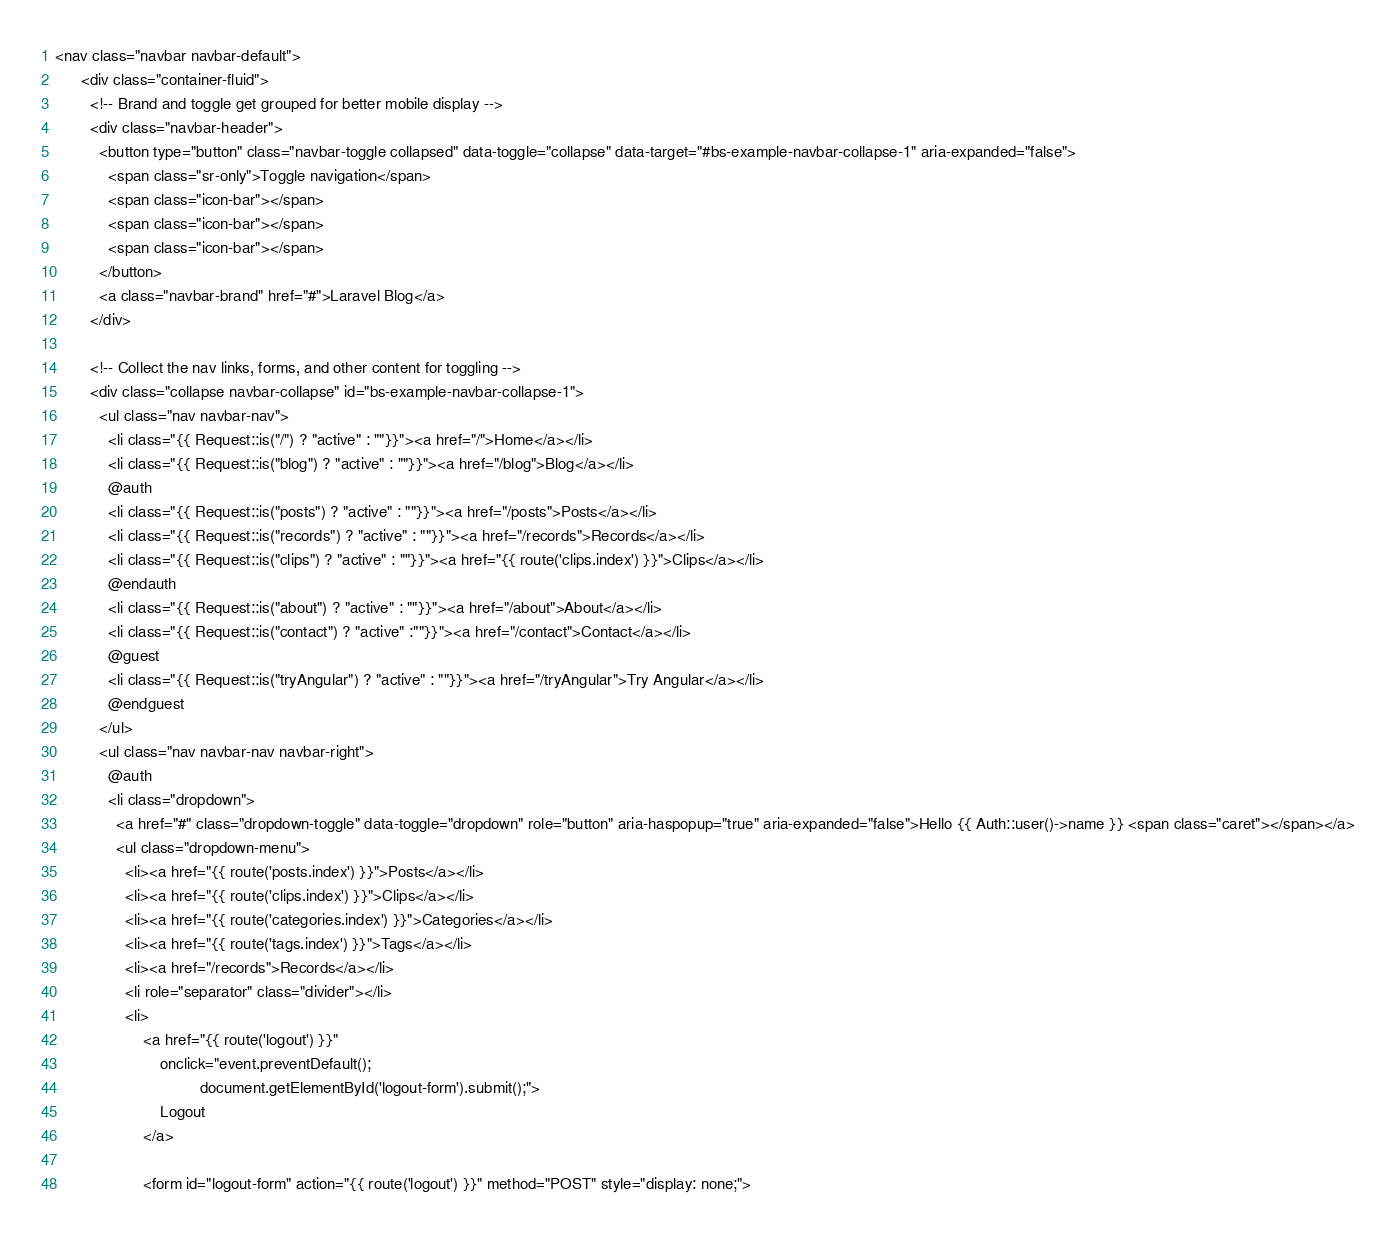<code> <loc_0><loc_0><loc_500><loc_500><_PHP_><nav class="navbar navbar-default">
      <div class="container-fluid">
        <!-- Brand and toggle get grouped for better mobile display -->
        <div class="navbar-header">
          <button type="button" class="navbar-toggle collapsed" data-toggle="collapse" data-target="#bs-example-navbar-collapse-1" aria-expanded="false">
            <span class="sr-only">Toggle navigation</span>
            <span class="icon-bar"></span>
            <span class="icon-bar"></span>
            <span class="icon-bar"></span>
          </button>
          <a class="navbar-brand" href="#">Laravel Blog</a>
        </div>

        <!-- Collect the nav links, forms, and other content for toggling -->
        <div class="collapse navbar-collapse" id="bs-example-navbar-collapse-1">
          <ul class="nav navbar-nav">
            <li class="{{ Request::is("/") ? "active" : ""}}"><a href="/">Home</a></li>
            <li class="{{ Request::is("blog") ? "active" : ""}}"><a href="/blog">Blog</a></li>
            @auth
            <li class="{{ Request::is("posts") ? "active" : ""}}"><a href="/posts">Posts</a></li>
            <li class="{{ Request::is("records") ? "active" : ""}}"><a href="/records">Records</a></li>
            <li class="{{ Request::is("clips") ? "active" : ""}}"><a href="{{ route('clips.index') }}">Clips</a></li>
            @endauth
            <li class="{{ Request::is("about") ? "active" : ""}}"><a href="/about">About</a></li>
            <li class="{{ Request::is("contact") ? "active" :""}}"><a href="/contact">Contact</a></li>
            @guest
            <li class="{{ Request::is("tryAngular") ? "active" : ""}}"><a href="/tryAngular">Try Angular</a></li>
            @endguest
          </ul>
          <ul class="nav navbar-nav navbar-right">
            @auth
            <li class="dropdown">
              <a href="#" class="dropdown-toggle" data-toggle="dropdown" role="button" aria-haspopup="true" aria-expanded="false">Hello {{ Auth::user()->name }} <span class="caret"></span></a>
              <ul class="dropdown-menu">
                <li><a href="{{ route('posts.index') }}">Posts</a></li>
                <li><a href="{{ route('clips.index') }}">Clips</a></li>
                <li><a href="{{ route('categories.index') }}">Categories</a></li>
                <li><a href="{{ route('tags.index') }}">Tags</a></li>
                <li><a href="/records">Records</a></li>
                <li role="separator" class="divider"></li>
                <li>
                    <a href="{{ route('logout') }}"
                        onclick="event.preventDefault();
                                 document.getElementById('logout-form').submit();">
                        Logout
                    </a>

                    <form id="logout-form" action="{{ route('logout') }}" method="POST" style="display: none;"></code> 